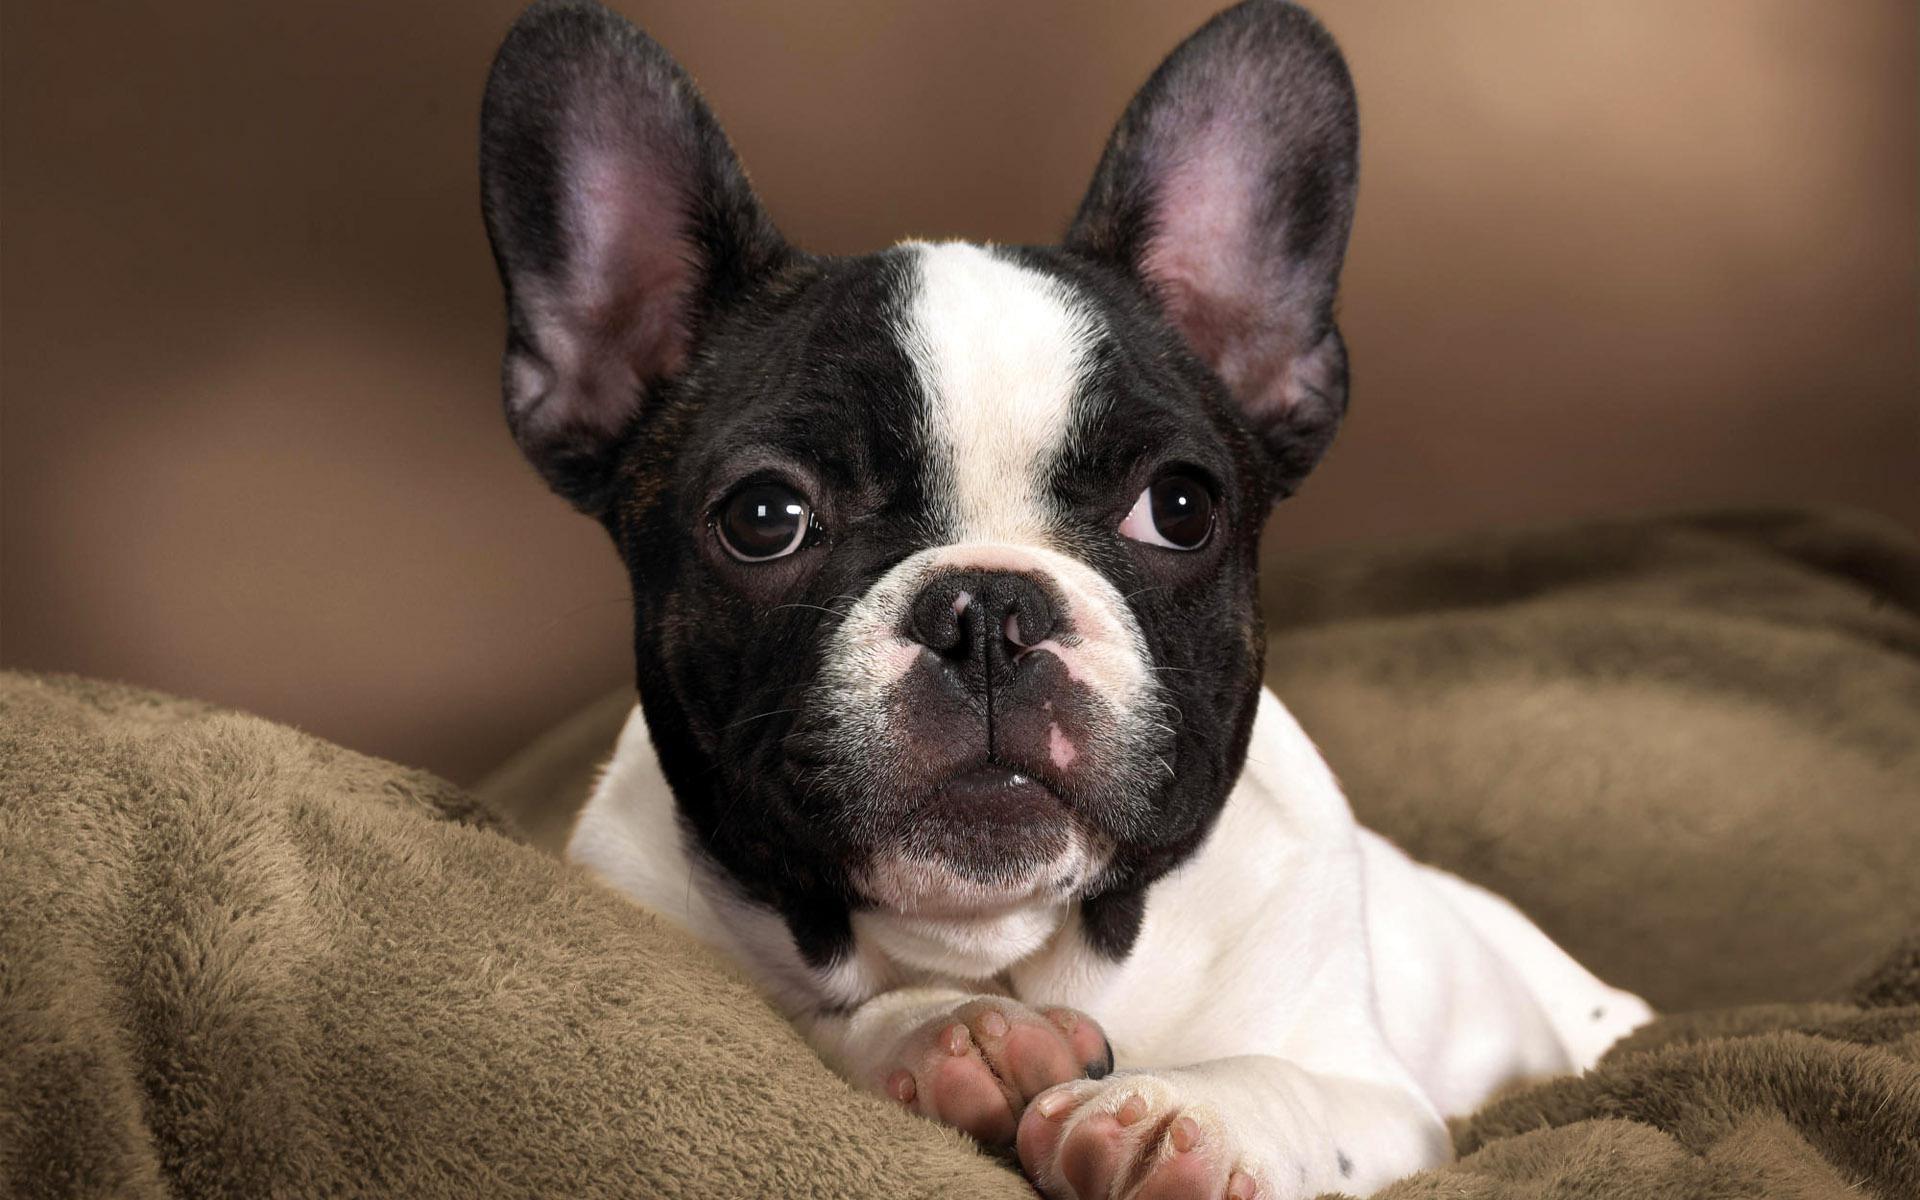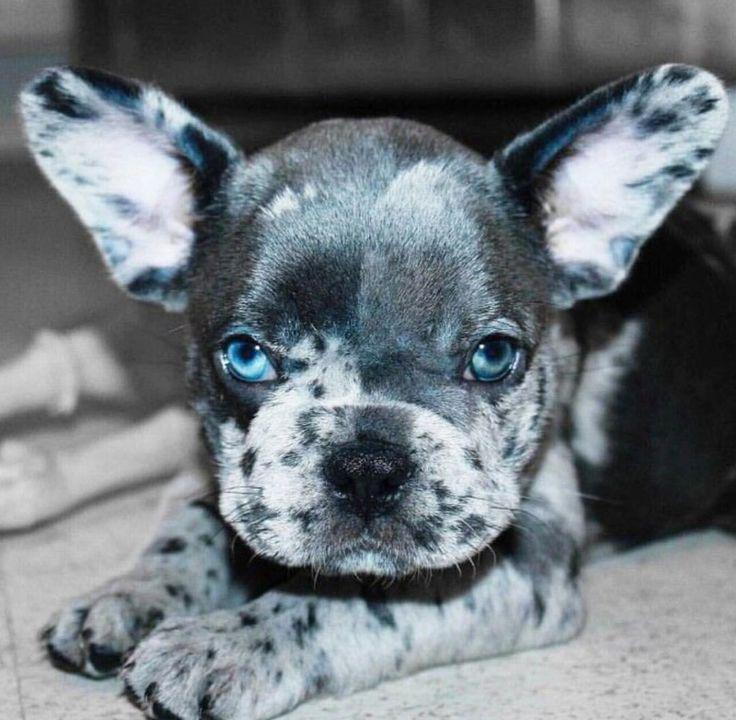The first image is the image on the left, the second image is the image on the right. Evaluate the accuracy of this statement regarding the images: "Each image shows one sitting dog with black-and-white coloring, at least on its face.". Is it true? Answer yes or no. No. 